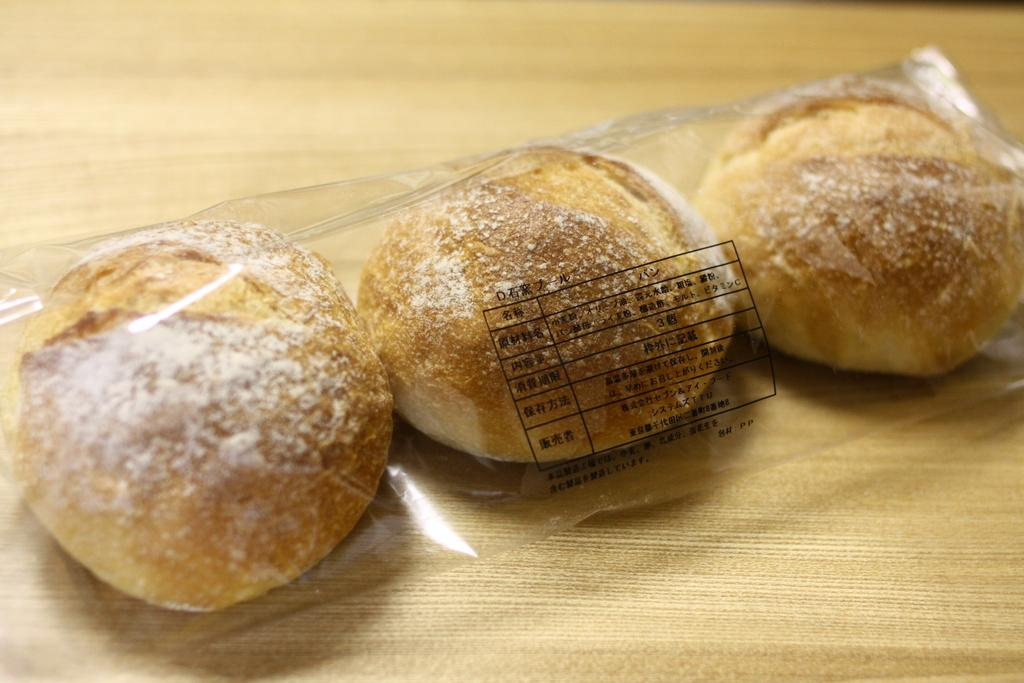What type of items can be seen in the image? There are eatables in the image. How are the eatables contained or protected? The eatables are placed in a plastic cover. Where is the plastic cover with eatables located? The plastic cover with eatables is placed on a table. Can you describe the background of the image? The background of the image is blurred. What advice does the son give to his father in the image? There is no son or father present in the image, and therefore no advice can be given or received. 